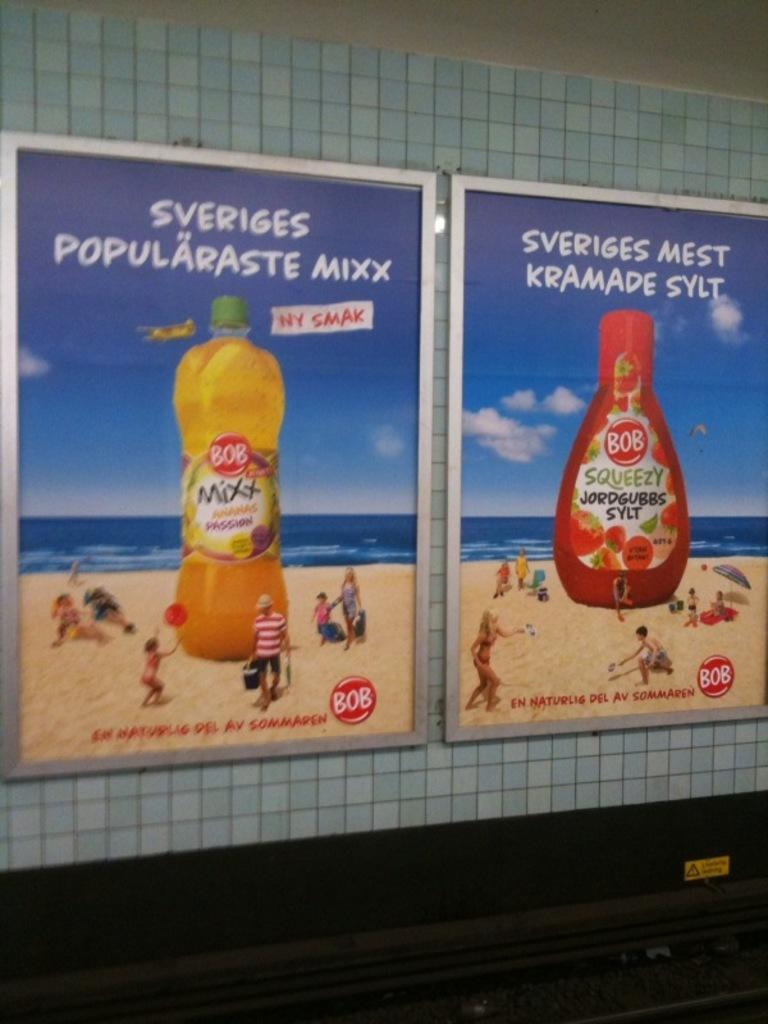<image>
Present a compact description of the photo's key features. Two ads for Bob products are side by side on a wall. 